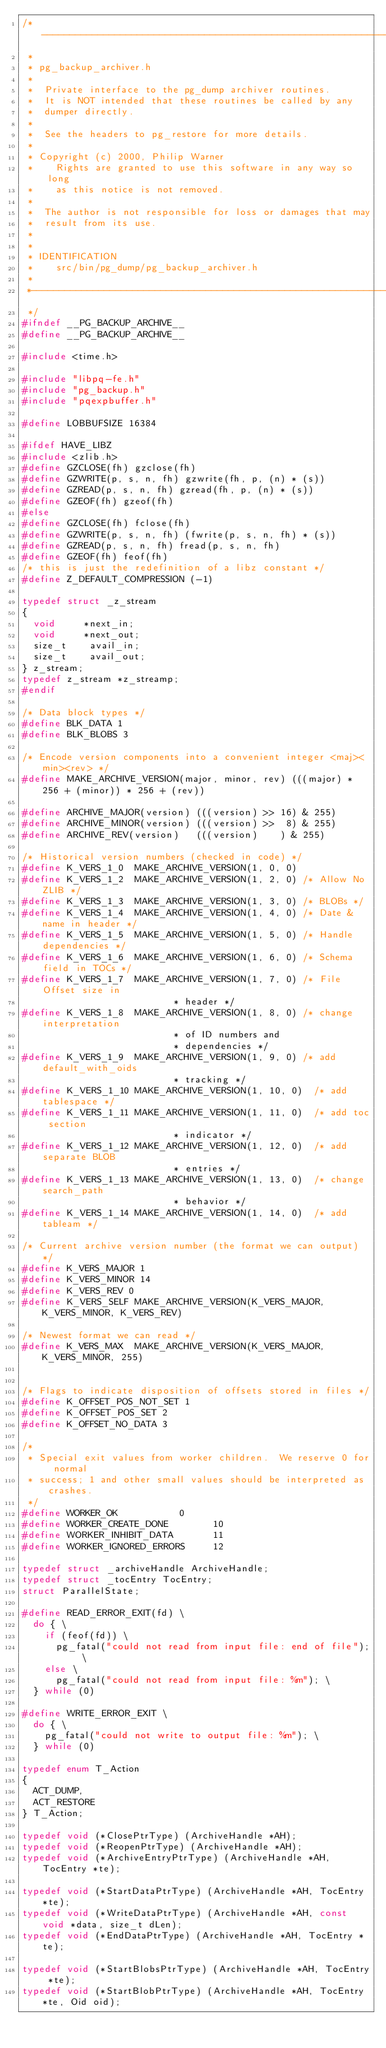Convert code to text. <code><loc_0><loc_0><loc_500><loc_500><_C_>/*-------------------------------------------------------------------------
 *
 * pg_backup_archiver.h
 *
 *	Private interface to the pg_dump archiver routines.
 *	It is NOT intended that these routines be called by any
 *	dumper directly.
 *
 *	See the headers to pg_restore for more details.
 *
 * Copyright (c) 2000, Philip Warner
 *		Rights are granted to use this software in any way so long
 *		as this notice is not removed.
 *
 *	The author is not responsible for loss or damages that may
 *	result from its use.
 *
 *
 * IDENTIFICATION
 *		src/bin/pg_dump/pg_backup_archiver.h
 *
 *-------------------------------------------------------------------------
 */
#ifndef __PG_BACKUP_ARCHIVE__
#define __PG_BACKUP_ARCHIVE__

#include <time.h>

#include "libpq-fe.h"
#include "pg_backup.h"
#include "pqexpbuffer.h"

#define LOBBUFSIZE 16384

#ifdef HAVE_LIBZ
#include <zlib.h>
#define GZCLOSE(fh) gzclose(fh)
#define GZWRITE(p, s, n, fh) gzwrite(fh, p, (n) * (s))
#define GZREAD(p, s, n, fh) gzread(fh, p, (n) * (s))
#define GZEOF(fh)	gzeof(fh)
#else
#define GZCLOSE(fh) fclose(fh)
#define GZWRITE(p, s, n, fh) (fwrite(p, s, n, fh) * (s))
#define GZREAD(p, s, n, fh) fread(p, s, n, fh)
#define GZEOF(fh)	feof(fh)
/* this is just the redefinition of a libz constant */
#define Z_DEFAULT_COMPRESSION (-1)

typedef struct _z_stream
{
	void	   *next_in;
	void	   *next_out;
	size_t		avail_in;
	size_t		avail_out;
} z_stream;
typedef z_stream *z_streamp;
#endif

/* Data block types */
#define BLK_DATA 1
#define BLK_BLOBS 3

/* Encode version components into a convenient integer <maj><min><rev> */
#define MAKE_ARCHIVE_VERSION(major, minor, rev) (((major) * 256 + (minor)) * 256 + (rev))

#define ARCHIVE_MAJOR(version) (((version) >> 16) & 255)
#define ARCHIVE_MINOR(version) (((version) >>  8) & 255)
#define ARCHIVE_REV(version)   (((version)		) & 255)

/* Historical version numbers (checked in code) */
#define K_VERS_1_0	MAKE_ARCHIVE_VERSION(1, 0, 0)
#define K_VERS_1_2	MAKE_ARCHIVE_VERSION(1, 2, 0)	/* Allow No ZLIB */
#define K_VERS_1_3	MAKE_ARCHIVE_VERSION(1, 3, 0)	/* BLOBs */
#define K_VERS_1_4	MAKE_ARCHIVE_VERSION(1, 4, 0)	/* Date & name in header */
#define K_VERS_1_5	MAKE_ARCHIVE_VERSION(1, 5, 0)	/* Handle dependencies */
#define K_VERS_1_6	MAKE_ARCHIVE_VERSION(1, 6, 0)	/* Schema field in TOCs */
#define K_VERS_1_7	MAKE_ARCHIVE_VERSION(1, 7, 0)	/* File Offset size in
													 * header */
#define K_VERS_1_8	MAKE_ARCHIVE_VERSION(1, 8, 0)	/* change interpretation
													 * of ID numbers and
													 * dependencies */
#define K_VERS_1_9	MAKE_ARCHIVE_VERSION(1, 9, 0)	/* add default_with_oids
													 * tracking */
#define K_VERS_1_10 MAKE_ARCHIVE_VERSION(1, 10, 0)	/* add tablespace */
#define K_VERS_1_11 MAKE_ARCHIVE_VERSION(1, 11, 0)	/* add toc section
													 * indicator */
#define K_VERS_1_12 MAKE_ARCHIVE_VERSION(1, 12, 0)	/* add separate BLOB
													 * entries */
#define K_VERS_1_13 MAKE_ARCHIVE_VERSION(1, 13, 0)	/* change search_path
													 * behavior */
#define K_VERS_1_14 MAKE_ARCHIVE_VERSION(1, 14, 0)	/* add tableam */

/* Current archive version number (the format we can output) */
#define K_VERS_MAJOR 1
#define K_VERS_MINOR 14
#define K_VERS_REV 0
#define K_VERS_SELF MAKE_ARCHIVE_VERSION(K_VERS_MAJOR, K_VERS_MINOR, K_VERS_REV)

/* Newest format we can read */
#define K_VERS_MAX	MAKE_ARCHIVE_VERSION(K_VERS_MAJOR, K_VERS_MINOR, 255)


/* Flags to indicate disposition of offsets stored in files */
#define K_OFFSET_POS_NOT_SET 1
#define K_OFFSET_POS_SET 2
#define K_OFFSET_NO_DATA 3

/*
 * Special exit values from worker children.  We reserve 0 for normal
 * success; 1 and other small values should be interpreted as crashes.
 */
#define WORKER_OK					  0
#define WORKER_CREATE_DONE			  10
#define WORKER_INHIBIT_DATA			  11
#define WORKER_IGNORED_ERRORS		  12

typedef struct _archiveHandle ArchiveHandle;
typedef struct _tocEntry TocEntry;
struct ParallelState;

#define READ_ERROR_EXIT(fd) \
	do { \
		if (feof(fd)) \
			pg_fatal("could not read from input file: end of file"); \
		else \
			pg_fatal("could not read from input file: %m"); \
	} while (0)

#define WRITE_ERROR_EXIT \
	do { \
		pg_fatal("could not write to output file: %m"); \
	} while (0)

typedef enum T_Action
{
	ACT_DUMP,
	ACT_RESTORE
} T_Action;

typedef void (*ClosePtrType) (ArchiveHandle *AH);
typedef void (*ReopenPtrType) (ArchiveHandle *AH);
typedef void (*ArchiveEntryPtrType) (ArchiveHandle *AH, TocEntry *te);

typedef void (*StartDataPtrType) (ArchiveHandle *AH, TocEntry *te);
typedef void (*WriteDataPtrType) (ArchiveHandle *AH, const void *data, size_t dLen);
typedef void (*EndDataPtrType) (ArchiveHandle *AH, TocEntry *te);

typedef void (*StartBlobsPtrType) (ArchiveHandle *AH, TocEntry *te);
typedef void (*StartBlobPtrType) (ArchiveHandle *AH, TocEntry *te, Oid oid);</code> 